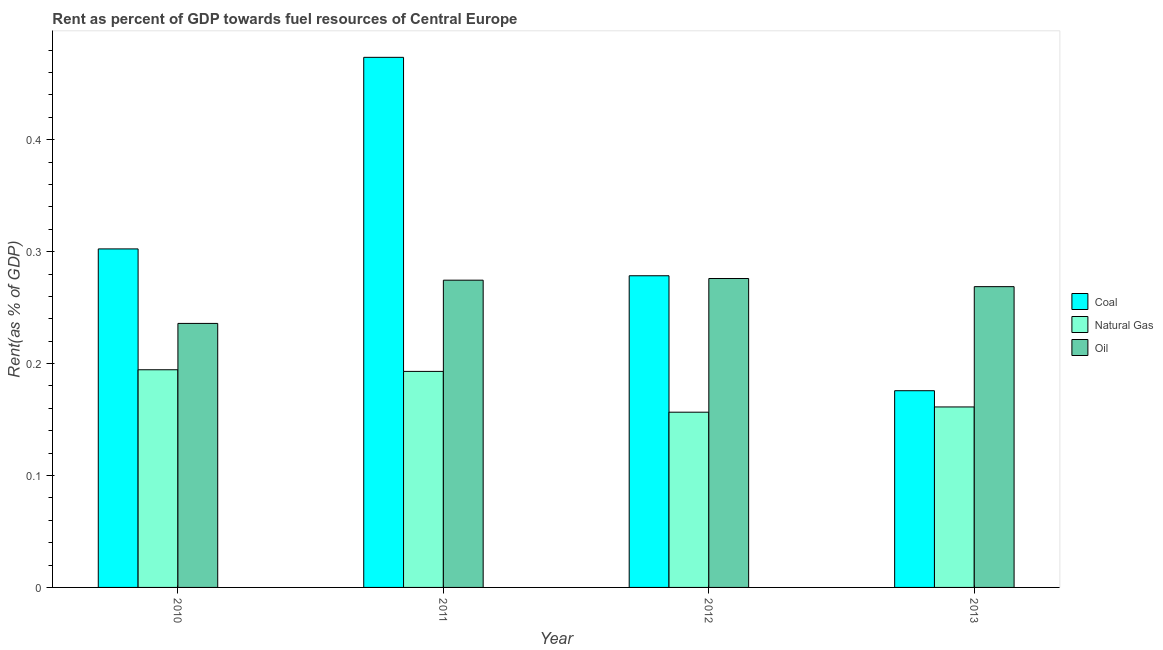Are the number of bars on each tick of the X-axis equal?
Make the answer very short. Yes. How many bars are there on the 1st tick from the left?
Ensure brevity in your answer.  3. In how many cases, is the number of bars for a given year not equal to the number of legend labels?
Your response must be concise. 0. What is the rent towards oil in 2012?
Ensure brevity in your answer.  0.28. Across all years, what is the maximum rent towards natural gas?
Offer a very short reply. 0.19. Across all years, what is the minimum rent towards coal?
Make the answer very short. 0.18. What is the total rent towards natural gas in the graph?
Offer a very short reply. 0.71. What is the difference between the rent towards natural gas in 2011 and that in 2013?
Make the answer very short. 0.03. What is the difference between the rent towards oil in 2010 and the rent towards coal in 2012?
Give a very brief answer. -0.04. What is the average rent towards coal per year?
Keep it short and to the point. 0.31. In how many years, is the rent towards coal greater than 0.06 %?
Offer a terse response. 4. What is the ratio of the rent towards natural gas in 2011 to that in 2012?
Give a very brief answer. 1.23. What is the difference between the highest and the second highest rent towards oil?
Your answer should be very brief. 0. What is the difference between the highest and the lowest rent towards oil?
Your answer should be compact. 0.04. What does the 1st bar from the left in 2011 represents?
Ensure brevity in your answer.  Coal. What does the 3rd bar from the right in 2013 represents?
Ensure brevity in your answer.  Coal. Are all the bars in the graph horizontal?
Offer a very short reply. No. How many years are there in the graph?
Give a very brief answer. 4. What is the difference between two consecutive major ticks on the Y-axis?
Your answer should be compact. 0.1. Are the values on the major ticks of Y-axis written in scientific E-notation?
Your response must be concise. No. How many legend labels are there?
Your response must be concise. 3. What is the title of the graph?
Provide a short and direct response. Rent as percent of GDP towards fuel resources of Central Europe. What is the label or title of the X-axis?
Your response must be concise. Year. What is the label or title of the Y-axis?
Your answer should be compact. Rent(as % of GDP). What is the Rent(as % of GDP) in Coal in 2010?
Your response must be concise. 0.3. What is the Rent(as % of GDP) in Natural Gas in 2010?
Ensure brevity in your answer.  0.19. What is the Rent(as % of GDP) in Oil in 2010?
Provide a short and direct response. 0.24. What is the Rent(as % of GDP) in Coal in 2011?
Your response must be concise. 0.47. What is the Rent(as % of GDP) of Natural Gas in 2011?
Provide a short and direct response. 0.19. What is the Rent(as % of GDP) of Oil in 2011?
Provide a short and direct response. 0.27. What is the Rent(as % of GDP) of Coal in 2012?
Your response must be concise. 0.28. What is the Rent(as % of GDP) in Natural Gas in 2012?
Provide a succinct answer. 0.16. What is the Rent(as % of GDP) of Oil in 2012?
Keep it short and to the point. 0.28. What is the Rent(as % of GDP) in Coal in 2013?
Keep it short and to the point. 0.18. What is the Rent(as % of GDP) of Natural Gas in 2013?
Your response must be concise. 0.16. What is the Rent(as % of GDP) of Oil in 2013?
Offer a very short reply. 0.27. Across all years, what is the maximum Rent(as % of GDP) of Coal?
Give a very brief answer. 0.47. Across all years, what is the maximum Rent(as % of GDP) in Natural Gas?
Offer a very short reply. 0.19. Across all years, what is the maximum Rent(as % of GDP) in Oil?
Make the answer very short. 0.28. Across all years, what is the minimum Rent(as % of GDP) of Coal?
Your answer should be compact. 0.18. Across all years, what is the minimum Rent(as % of GDP) in Natural Gas?
Offer a very short reply. 0.16. Across all years, what is the minimum Rent(as % of GDP) of Oil?
Offer a very short reply. 0.24. What is the total Rent(as % of GDP) of Coal in the graph?
Ensure brevity in your answer.  1.23. What is the total Rent(as % of GDP) of Natural Gas in the graph?
Give a very brief answer. 0.71. What is the total Rent(as % of GDP) in Oil in the graph?
Provide a short and direct response. 1.06. What is the difference between the Rent(as % of GDP) in Coal in 2010 and that in 2011?
Offer a terse response. -0.17. What is the difference between the Rent(as % of GDP) in Natural Gas in 2010 and that in 2011?
Your answer should be compact. 0. What is the difference between the Rent(as % of GDP) of Oil in 2010 and that in 2011?
Provide a short and direct response. -0.04. What is the difference between the Rent(as % of GDP) of Coal in 2010 and that in 2012?
Provide a succinct answer. 0.02. What is the difference between the Rent(as % of GDP) of Natural Gas in 2010 and that in 2012?
Keep it short and to the point. 0.04. What is the difference between the Rent(as % of GDP) in Oil in 2010 and that in 2012?
Keep it short and to the point. -0.04. What is the difference between the Rent(as % of GDP) in Coal in 2010 and that in 2013?
Offer a terse response. 0.13. What is the difference between the Rent(as % of GDP) in Natural Gas in 2010 and that in 2013?
Offer a terse response. 0.03. What is the difference between the Rent(as % of GDP) of Oil in 2010 and that in 2013?
Offer a very short reply. -0.03. What is the difference between the Rent(as % of GDP) of Coal in 2011 and that in 2012?
Provide a short and direct response. 0.2. What is the difference between the Rent(as % of GDP) in Natural Gas in 2011 and that in 2012?
Your response must be concise. 0.04. What is the difference between the Rent(as % of GDP) in Oil in 2011 and that in 2012?
Your response must be concise. -0. What is the difference between the Rent(as % of GDP) of Coal in 2011 and that in 2013?
Your answer should be very brief. 0.3. What is the difference between the Rent(as % of GDP) in Natural Gas in 2011 and that in 2013?
Offer a terse response. 0.03. What is the difference between the Rent(as % of GDP) of Oil in 2011 and that in 2013?
Your response must be concise. 0.01. What is the difference between the Rent(as % of GDP) of Coal in 2012 and that in 2013?
Keep it short and to the point. 0.1. What is the difference between the Rent(as % of GDP) of Natural Gas in 2012 and that in 2013?
Provide a short and direct response. -0. What is the difference between the Rent(as % of GDP) of Oil in 2012 and that in 2013?
Provide a succinct answer. 0.01. What is the difference between the Rent(as % of GDP) of Coal in 2010 and the Rent(as % of GDP) of Natural Gas in 2011?
Your response must be concise. 0.11. What is the difference between the Rent(as % of GDP) in Coal in 2010 and the Rent(as % of GDP) in Oil in 2011?
Ensure brevity in your answer.  0.03. What is the difference between the Rent(as % of GDP) of Natural Gas in 2010 and the Rent(as % of GDP) of Oil in 2011?
Make the answer very short. -0.08. What is the difference between the Rent(as % of GDP) in Coal in 2010 and the Rent(as % of GDP) in Natural Gas in 2012?
Make the answer very short. 0.15. What is the difference between the Rent(as % of GDP) in Coal in 2010 and the Rent(as % of GDP) in Oil in 2012?
Your answer should be very brief. 0.03. What is the difference between the Rent(as % of GDP) of Natural Gas in 2010 and the Rent(as % of GDP) of Oil in 2012?
Provide a succinct answer. -0.08. What is the difference between the Rent(as % of GDP) in Coal in 2010 and the Rent(as % of GDP) in Natural Gas in 2013?
Ensure brevity in your answer.  0.14. What is the difference between the Rent(as % of GDP) of Coal in 2010 and the Rent(as % of GDP) of Oil in 2013?
Keep it short and to the point. 0.03. What is the difference between the Rent(as % of GDP) of Natural Gas in 2010 and the Rent(as % of GDP) of Oil in 2013?
Provide a succinct answer. -0.07. What is the difference between the Rent(as % of GDP) of Coal in 2011 and the Rent(as % of GDP) of Natural Gas in 2012?
Your response must be concise. 0.32. What is the difference between the Rent(as % of GDP) in Coal in 2011 and the Rent(as % of GDP) in Oil in 2012?
Your response must be concise. 0.2. What is the difference between the Rent(as % of GDP) of Natural Gas in 2011 and the Rent(as % of GDP) of Oil in 2012?
Offer a terse response. -0.08. What is the difference between the Rent(as % of GDP) of Coal in 2011 and the Rent(as % of GDP) of Natural Gas in 2013?
Keep it short and to the point. 0.31. What is the difference between the Rent(as % of GDP) in Coal in 2011 and the Rent(as % of GDP) in Oil in 2013?
Ensure brevity in your answer.  0.2. What is the difference between the Rent(as % of GDP) of Natural Gas in 2011 and the Rent(as % of GDP) of Oil in 2013?
Your answer should be compact. -0.08. What is the difference between the Rent(as % of GDP) in Coal in 2012 and the Rent(as % of GDP) in Natural Gas in 2013?
Offer a very short reply. 0.12. What is the difference between the Rent(as % of GDP) in Coal in 2012 and the Rent(as % of GDP) in Oil in 2013?
Provide a succinct answer. 0.01. What is the difference between the Rent(as % of GDP) of Natural Gas in 2012 and the Rent(as % of GDP) of Oil in 2013?
Offer a terse response. -0.11. What is the average Rent(as % of GDP) of Coal per year?
Provide a short and direct response. 0.31. What is the average Rent(as % of GDP) of Natural Gas per year?
Keep it short and to the point. 0.18. What is the average Rent(as % of GDP) in Oil per year?
Your response must be concise. 0.26. In the year 2010, what is the difference between the Rent(as % of GDP) of Coal and Rent(as % of GDP) of Natural Gas?
Ensure brevity in your answer.  0.11. In the year 2010, what is the difference between the Rent(as % of GDP) in Coal and Rent(as % of GDP) in Oil?
Your answer should be very brief. 0.07. In the year 2010, what is the difference between the Rent(as % of GDP) of Natural Gas and Rent(as % of GDP) of Oil?
Make the answer very short. -0.04. In the year 2011, what is the difference between the Rent(as % of GDP) of Coal and Rent(as % of GDP) of Natural Gas?
Make the answer very short. 0.28. In the year 2011, what is the difference between the Rent(as % of GDP) of Coal and Rent(as % of GDP) of Oil?
Give a very brief answer. 0.2. In the year 2011, what is the difference between the Rent(as % of GDP) of Natural Gas and Rent(as % of GDP) of Oil?
Your answer should be compact. -0.08. In the year 2012, what is the difference between the Rent(as % of GDP) in Coal and Rent(as % of GDP) in Natural Gas?
Give a very brief answer. 0.12. In the year 2012, what is the difference between the Rent(as % of GDP) of Coal and Rent(as % of GDP) of Oil?
Provide a short and direct response. 0. In the year 2012, what is the difference between the Rent(as % of GDP) in Natural Gas and Rent(as % of GDP) in Oil?
Your answer should be very brief. -0.12. In the year 2013, what is the difference between the Rent(as % of GDP) in Coal and Rent(as % of GDP) in Natural Gas?
Your answer should be compact. 0.01. In the year 2013, what is the difference between the Rent(as % of GDP) in Coal and Rent(as % of GDP) in Oil?
Make the answer very short. -0.09. In the year 2013, what is the difference between the Rent(as % of GDP) of Natural Gas and Rent(as % of GDP) of Oil?
Offer a very short reply. -0.11. What is the ratio of the Rent(as % of GDP) of Coal in 2010 to that in 2011?
Offer a terse response. 0.64. What is the ratio of the Rent(as % of GDP) in Natural Gas in 2010 to that in 2011?
Give a very brief answer. 1.01. What is the ratio of the Rent(as % of GDP) of Oil in 2010 to that in 2011?
Offer a very short reply. 0.86. What is the ratio of the Rent(as % of GDP) in Coal in 2010 to that in 2012?
Offer a terse response. 1.09. What is the ratio of the Rent(as % of GDP) in Natural Gas in 2010 to that in 2012?
Keep it short and to the point. 1.24. What is the ratio of the Rent(as % of GDP) in Oil in 2010 to that in 2012?
Offer a terse response. 0.85. What is the ratio of the Rent(as % of GDP) of Coal in 2010 to that in 2013?
Provide a short and direct response. 1.72. What is the ratio of the Rent(as % of GDP) in Natural Gas in 2010 to that in 2013?
Offer a terse response. 1.21. What is the ratio of the Rent(as % of GDP) in Oil in 2010 to that in 2013?
Keep it short and to the point. 0.88. What is the ratio of the Rent(as % of GDP) of Coal in 2011 to that in 2012?
Provide a short and direct response. 1.7. What is the ratio of the Rent(as % of GDP) of Natural Gas in 2011 to that in 2012?
Provide a short and direct response. 1.23. What is the ratio of the Rent(as % of GDP) of Coal in 2011 to that in 2013?
Give a very brief answer. 2.69. What is the ratio of the Rent(as % of GDP) of Natural Gas in 2011 to that in 2013?
Provide a succinct answer. 1.2. What is the ratio of the Rent(as % of GDP) in Oil in 2011 to that in 2013?
Give a very brief answer. 1.02. What is the ratio of the Rent(as % of GDP) in Coal in 2012 to that in 2013?
Offer a very short reply. 1.58. What is the ratio of the Rent(as % of GDP) of Natural Gas in 2012 to that in 2013?
Ensure brevity in your answer.  0.97. What is the ratio of the Rent(as % of GDP) of Oil in 2012 to that in 2013?
Your response must be concise. 1.03. What is the difference between the highest and the second highest Rent(as % of GDP) of Coal?
Give a very brief answer. 0.17. What is the difference between the highest and the second highest Rent(as % of GDP) in Natural Gas?
Your response must be concise. 0. What is the difference between the highest and the second highest Rent(as % of GDP) in Oil?
Your answer should be very brief. 0. What is the difference between the highest and the lowest Rent(as % of GDP) in Coal?
Provide a succinct answer. 0.3. What is the difference between the highest and the lowest Rent(as % of GDP) of Natural Gas?
Provide a succinct answer. 0.04. What is the difference between the highest and the lowest Rent(as % of GDP) of Oil?
Your answer should be very brief. 0.04. 